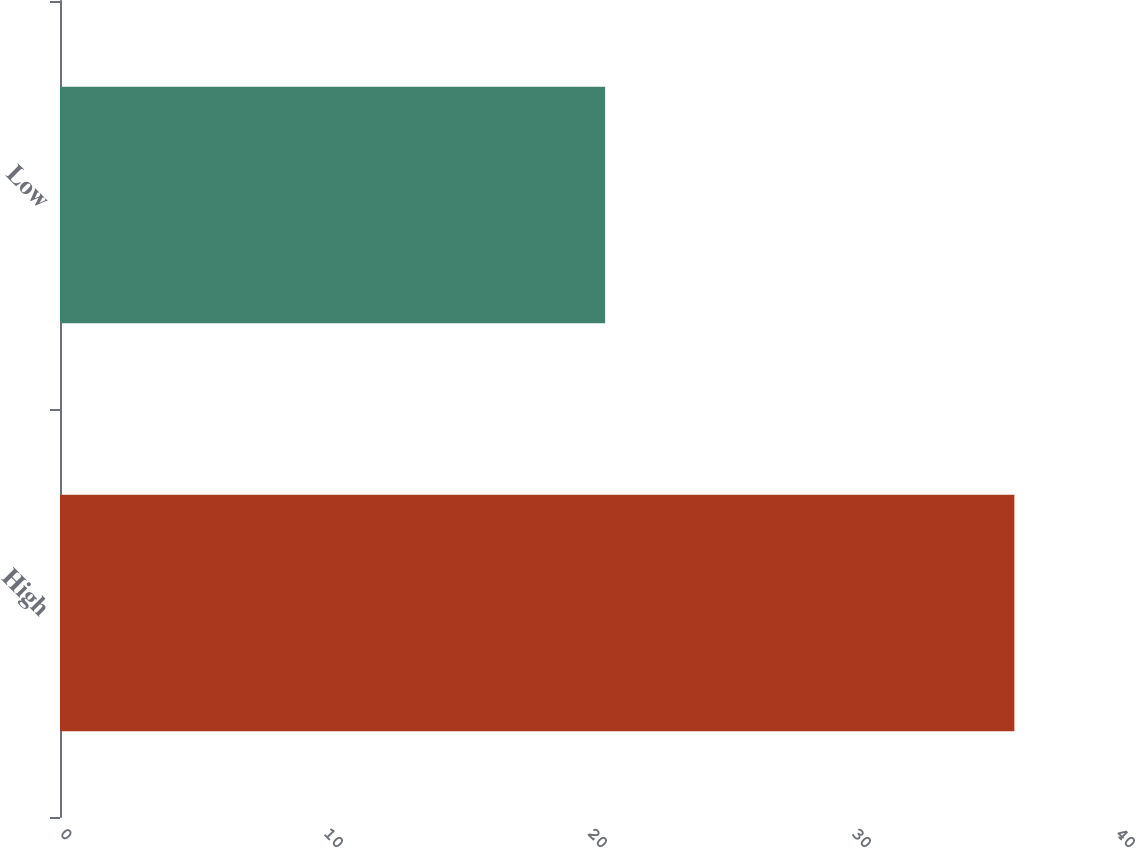Convert chart to OTSL. <chart><loc_0><loc_0><loc_500><loc_500><bar_chart><fcel>High<fcel>Low<nl><fcel>36.15<fcel>20.65<nl></chart> 